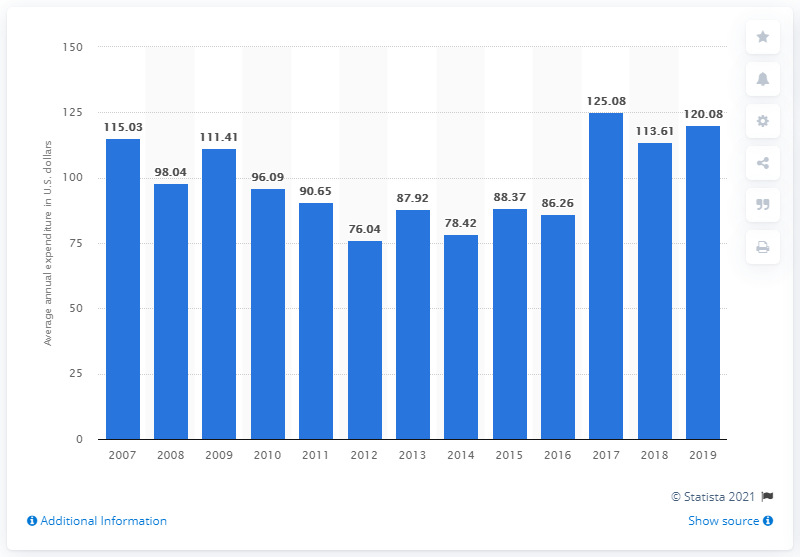Outline some significant characteristics in this image. In the United States in 2019, the average expenditure on lawn and garden supplies per consumer unit was $120.08. 